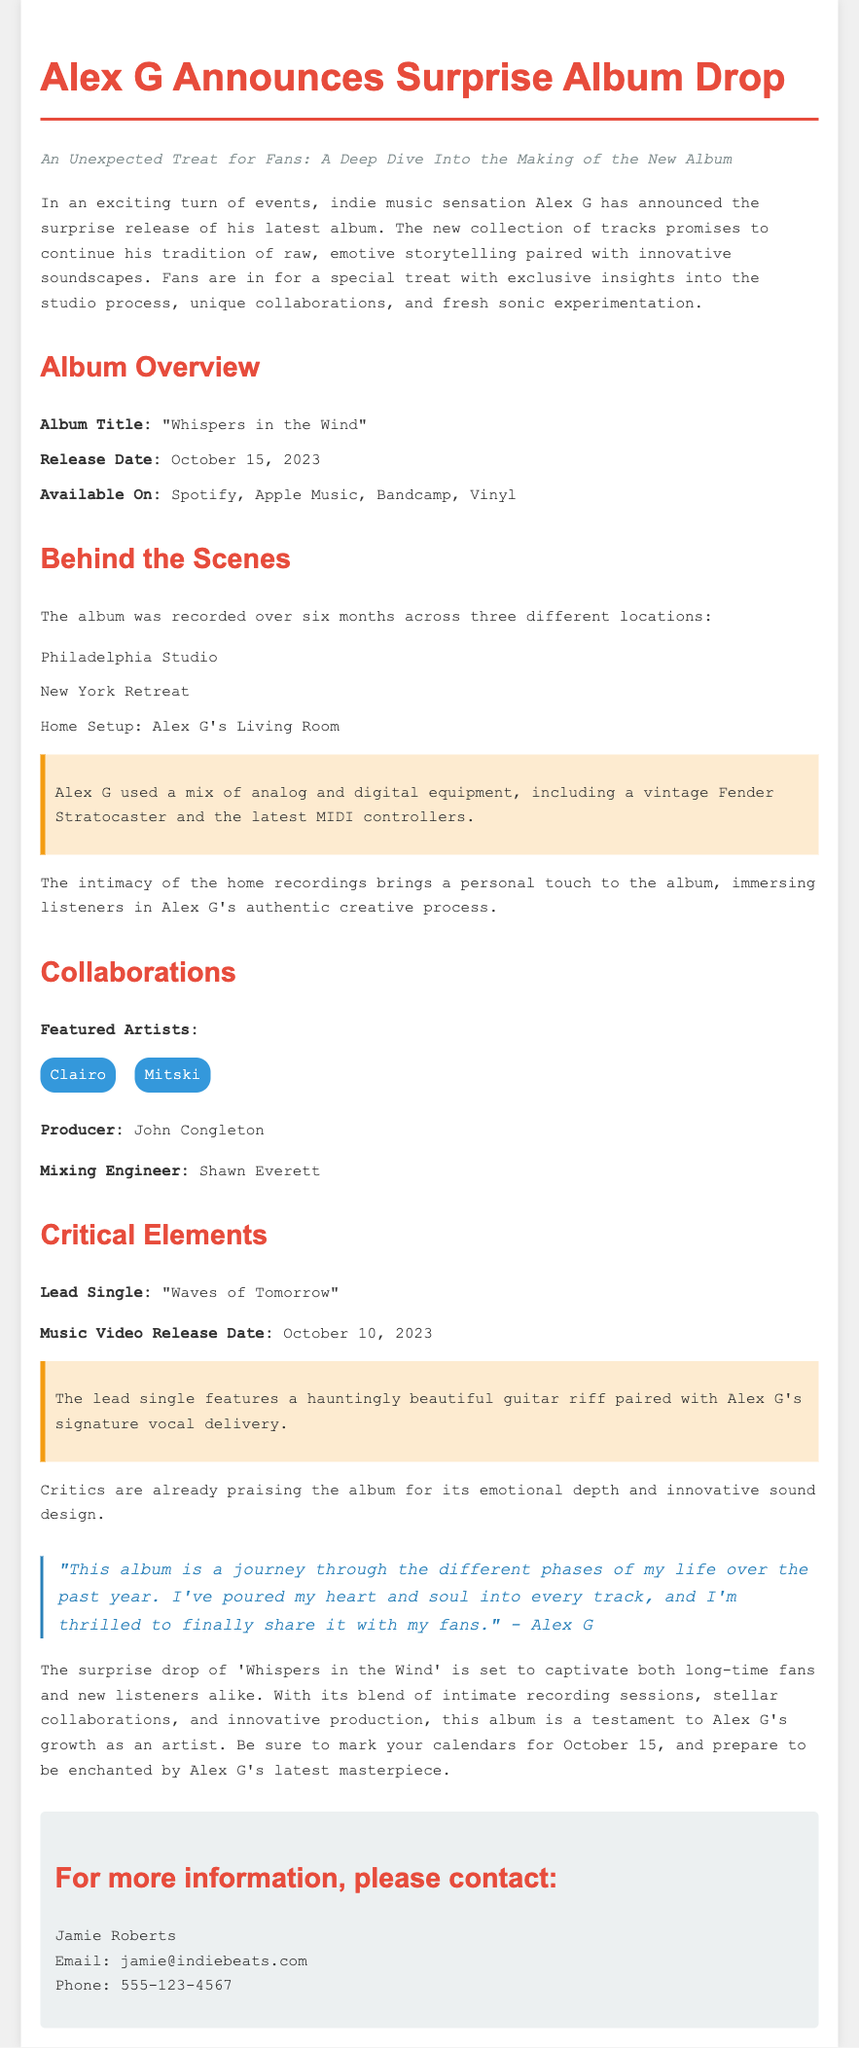What is the title of the new album? The title of the album is stated in the album overview section.
Answer: "Whispers in the Wind" When is the album release date? The release date is specified in the album overview section.
Answer: October 15, 2023 Where was the album recorded? The recording locations are listed in the behind-the-scenes section.
Answer: Philadelphia Studio, New York Retreat, Home Setup: Alex G's Living Room Who are the featured artists on the album? The featured artists are mentioned in the collaborations section.
Answer: Clairo, Mitski What is the title of the lead single? The lead single title is highlighted in the critical elements section.
Answer: "Waves of Tomorrow" Who produced the album? The producer's name is found in the collaborations section.
Answer: John Congleton What does Alex G describe this album as? Alex G's description of the album is quoted in the document.
Answer: "a journey through the different phases of my life over the past year" What platforms will the album be available on? The available platforms are listed in the album overview section.
Answer: Spotify, Apple Music, Bandcamp, Vinyl When will the music video be released? The release date for the music video is mentioned in the critical elements section.
Answer: October 10, 2023 